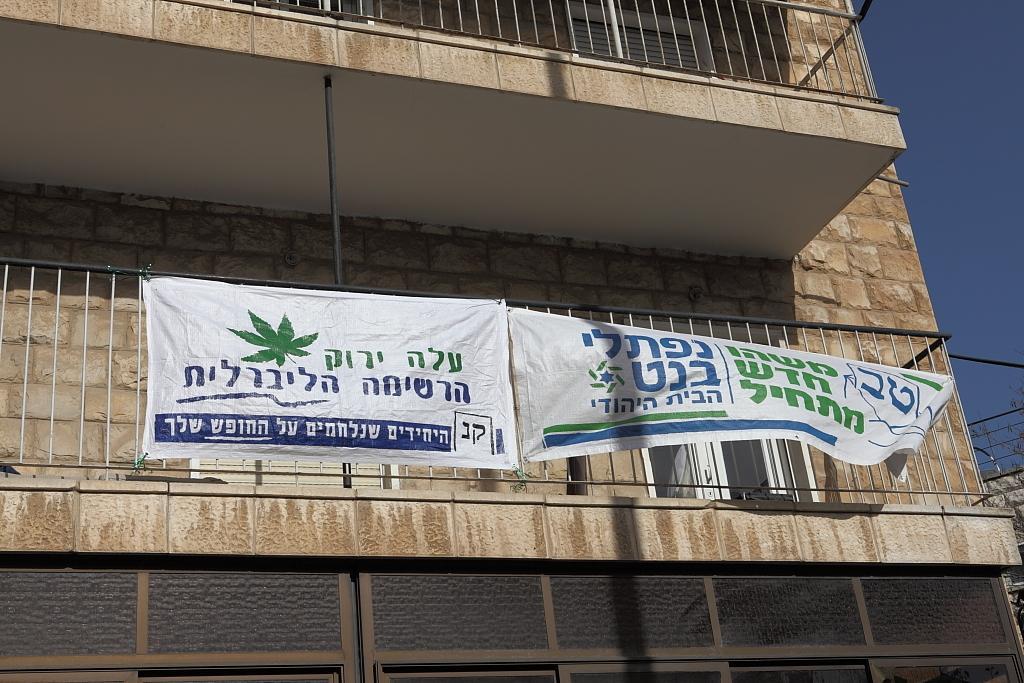Could you give a brief overview of what you see in this image? In this image we can see advertisements hanged to the railings of a building and sky. 